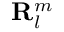Convert formula to latex. <formula><loc_0><loc_0><loc_500><loc_500>R _ { l } ^ { m }</formula> 